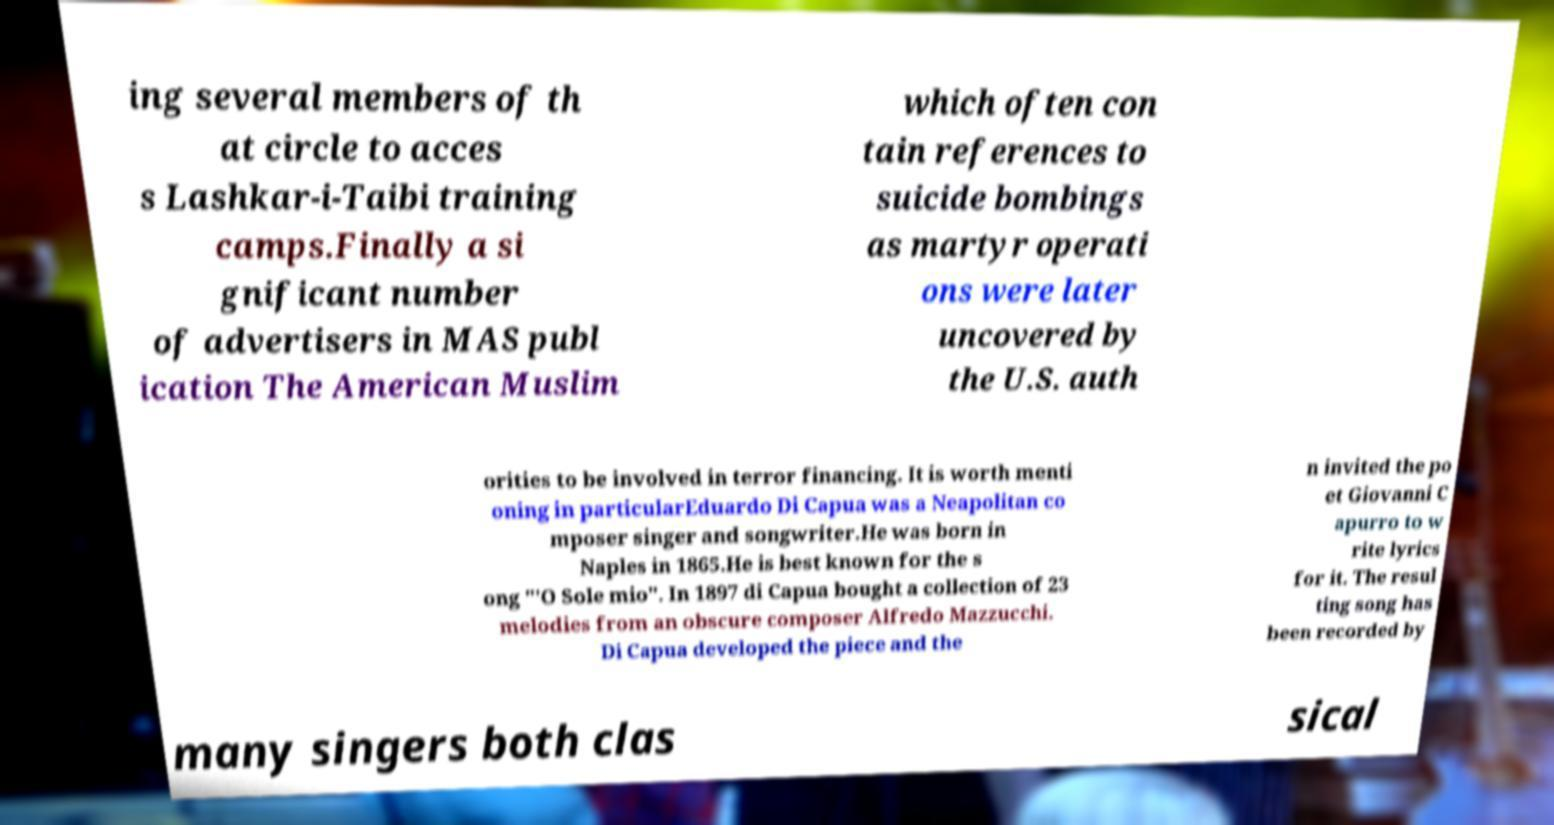There's text embedded in this image that I need extracted. Can you transcribe it verbatim? ing several members of th at circle to acces s Lashkar-i-Taibi training camps.Finally a si gnificant number of advertisers in MAS publ ication The American Muslim which often con tain references to suicide bombings as martyr operati ons were later uncovered by the U.S. auth orities to be involved in terror financing. It is worth menti oning in particularEduardo Di Capua was a Neapolitan co mposer singer and songwriter.He was born in Naples in 1865.He is best known for the s ong "'O Sole mio". In 1897 di Capua bought a collection of 23 melodies from an obscure composer Alfredo Mazzucchi. Di Capua developed the piece and the n invited the po et Giovanni C apurro to w rite lyrics for it. The resul ting song has been recorded by many singers both clas sical 